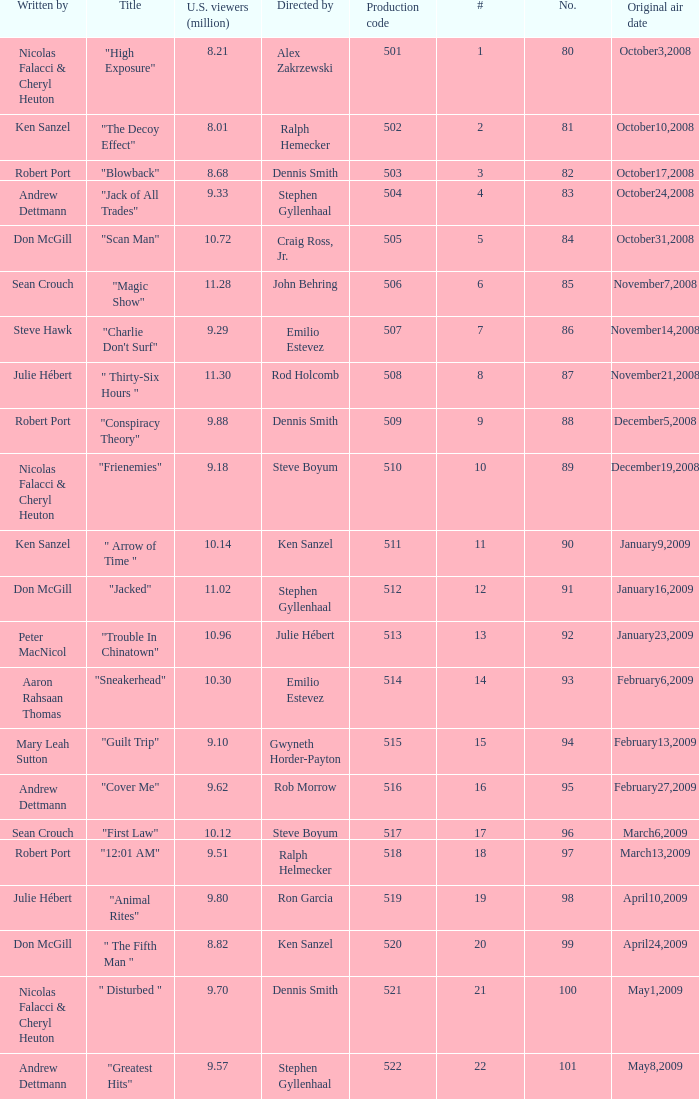What episode had 10.14 million viewers (U.S.)? 11.0. 